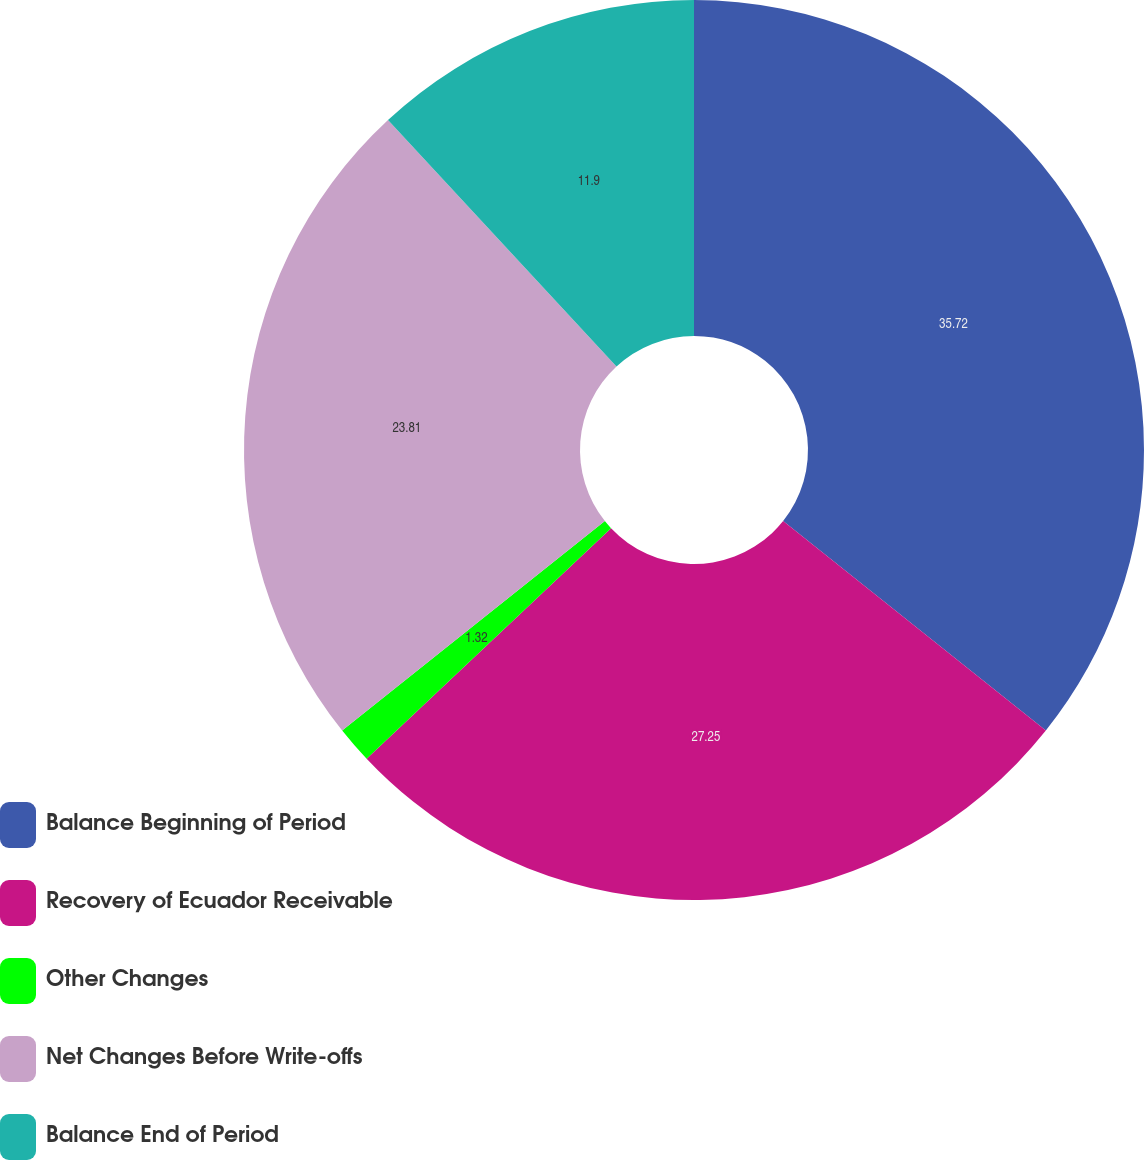Convert chart to OTSL. <chart><loc_0><loc_0><loc_500><loc_500><pie_chart><fcel>Balance Beginning of Period<fcel>Recovery of Ecuador Receivable<fcel>Other Changes<fcel>Net Changes Before Write-offs<fcel>Balance End of Period<nl><fcel>35.71%<fcel>27.25%<fcel>1.32%<fcel>23.81%<fcel>11.9%<nl></chart> 